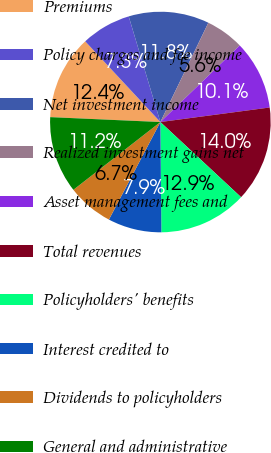Convert chart. <chart><loc_0><loc_0><loc_500><loc_500><pie_chart><fcel>Premiums<fcel>Policy charges and fee income<fcel>Net investment income<fcel>Realized investment gains net<fcel>Asset management fees and<fcel>Total revenues<fcel>Policyholders' benefits<fcel>Interest credited to<fcel>Dividends to policyholders<fcel>General and administrative<nl><fcel>12.36%<fcel>7.3%<fcel>11.8%<fcel>5.62%<fcel>10.11%<fcel>14.04%<fcel>12.92%<fcel>7.87%<fcel>6.74%<fcel>11.24%<nl></chart> 